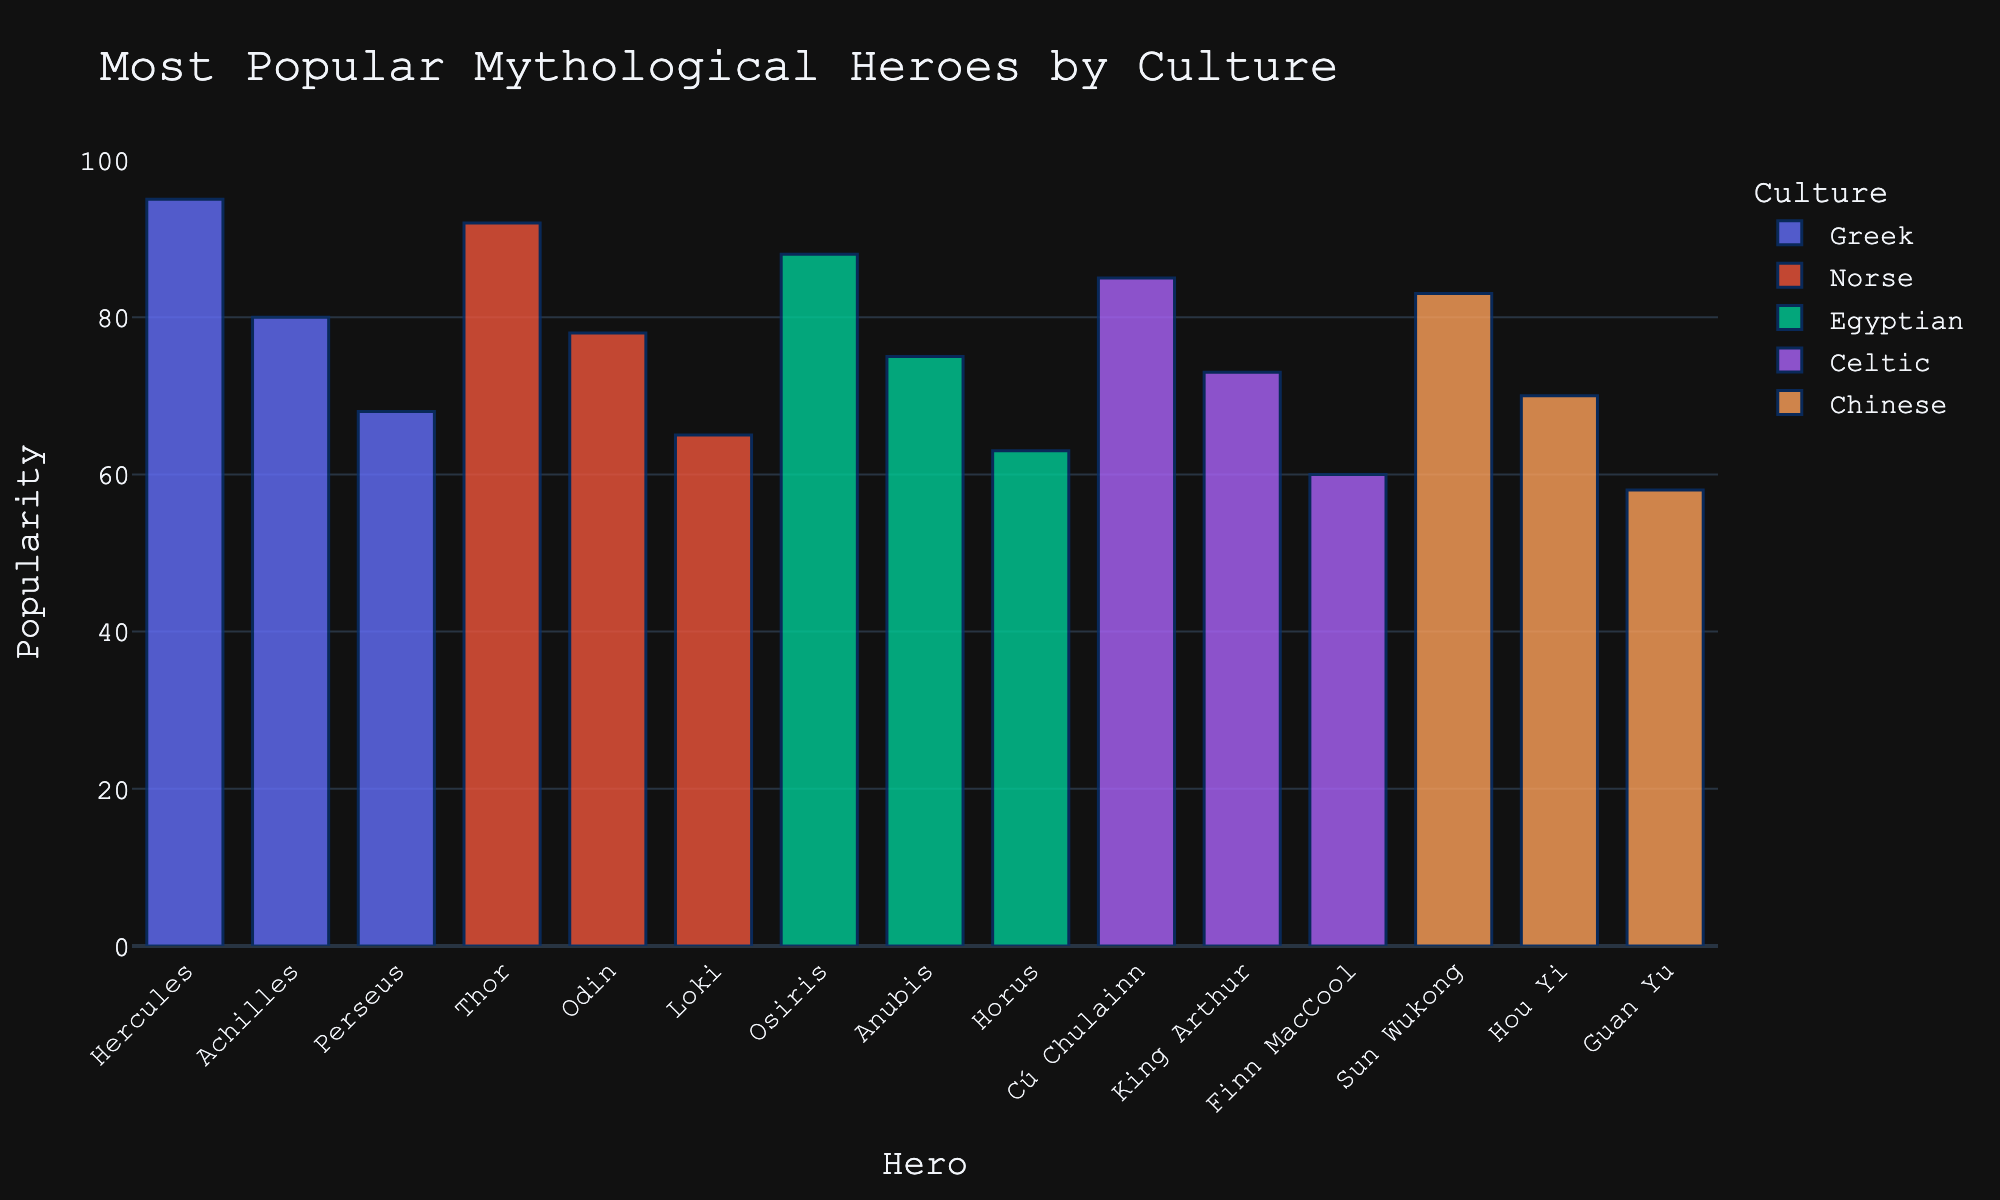Which hero has the highest popularity score? To find the hero with the highest popularity score, look at the heights of the bars and identify the tallest one. Hercules from Greek mythology has the highest score with a popularity of 95.
Answer: Hercules How many cultures have heroes in the top 5 most popular list? Examine the colors representing different cultures within the top 5 heroes. The first five heroes on the chart are Hercules (Greek), Thor (Norse), Osiris (Egyptian), Cú Chulainn (Celtic), and Sun Wukong (Chinese). This covers all the listed cultures.
Answer: 5 What is the total popularity score of the top 3 Greek heroes? Identify the heroes from Greek culture and sum up the scores of the top 3. The heroes are Hercules (95), Achilles (80), and Perseus (68). The total is 95 + 80 + 68 = 243.
Answer: 243 Who is more popular, Thor from Norse mythology or Osiris from Egyptian mythology, and by how much? Compare the scores of Thor (92) and Osiris (88) by subtracting the lower score from the higher score. 92 - 88 = 4. Thus, Thor is more popular by 4 points.
Answer: Thor by 4 points What's the difference in popularity score between the most popular Greek hero and the least popular Chinese hero in the top 5? Identify the scores associated with Hercules (Greek, 95) and Sun Wukong (Chinese, 83). Subtract the lower score from the higher score: 95 - 83 = 12.
Answer: 12 Which culture has the least popular hero in the top 5, and what is the hero's name? Examine the top 5 heroes and identify the one with the lowest popularity score. Sun Wukong from Chinese mythology has the lowest score of 83.
Answer: Chinese, Sun Wukong What's the average popularity score of the top 5 heroes? Add the popularity scores of the top 5 heroes and divide by 5. The scores are 95, 92, 88, 85, and 83. The sum is 95 + 92 + 88 + 85 + 83 = 443, and the average is 443 / 5 = 88.6.
Answer: 88.6 Which has more heroes in the top 10, Norse or Egyptian mythology, and how many more? Identify the top 10 heroes and count the heroes from Norse and Egyptian mythologies. Norse has Thor (2nd) and Odin (9th), while Egyptian has Osiris (3rd), Anubis (8th), and Horus (13th). Norse has 2 and Egyptian has 3. Egyptian has 1 more hero.
Answer: Egyptian by 1 